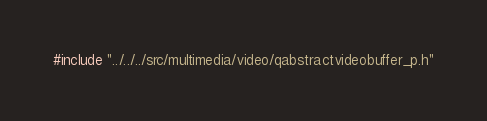Convert code to text. <code><loc_0><loc_0><loc_500><loc_500><_C_>#include "../../../src/multimedia/video/qabstractvideobuffer_p.h"
</code> 